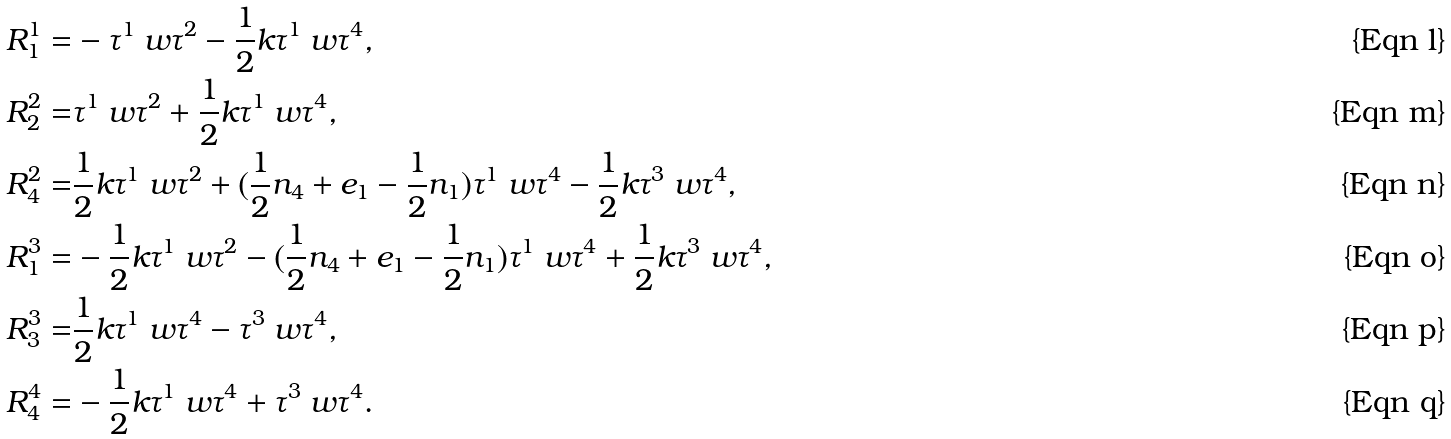Convert formula to latex. <formula><loc_0><loc_0><loc_500><loc_500>R ^ { 1 } _ { 1 } = & - \tau ^ { 1 } \ w \tau ^ { 2 } - \frac { 1 } { 2 } k \tau ^ { 1 } \ w \tau ^ { 4 } , \\ R ^ { 2 } _ { 2 } = & \tau ^ { 1 } \ w \tau ^ { 2 } + \frac { 1 } { 2 } k \tau ^ { 1 } \ w \tau ^ { 4 } , \\ R ^ { 2 } _ { 4 } = & \frac { 1 } { 2 } k \tau ^ { 1 } \ w \tau ^ { 2 } + ( \frac { 1 } { 2 } n _ { 4 } + e _ { 1 } - \frac { 1 } { 2 } n _ { 1 } ) \tau ^ { 1 } \ w \tau ^ { 4 } - \frac { 1 } { 2 } k \tau ^ { 3 } \ w \tau ^ { 4 } , \\ R ^ { 3 } _ { 1 } = & - \frac { 1 } { 2 } k \tau ^ { 1 } \ w \tau ^ { 2 } - ( \frac { 1 } { 2 } n _ { 4 } + e _ { 1 } - \frac { 1 } { 2 } n _ { 1 } ) \tau ^ { 1 } \ w \tau ^ { 4 } + \frac { 1 } { 2 } k \tau ^ { 3 } \ w \tau ^ { 4 } , \\ R ^ { 3 } _ { 3 } = & \frac { 1 } { 2 } k \tau ^ { 1 } \ w \tau ^ { 4 } - \tau ^ { 3 } \ w \tau ^ { 4 } , \\ R ^ { 4 } _ { 4 } = & - \frac { 1 } { 2 } k \tau ^ { 1 } \ w \tau ^ { 4 } + \tau ^ { 3 } \ w \tau ^ { 4 } .</formula> 